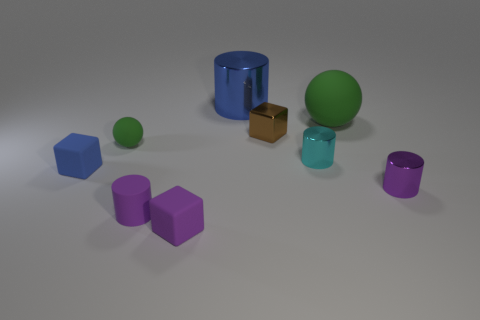Does the green rubber thing that is behind the brown cube have the same shape as the cyan metallic object?
Provide a short and direct response. No. What shape is the tiny blue object?
Provide a short and direct response. Cube. What number of small blue cubes are made of the same material as the big green sphere?
Keep it short and to the point. 1. There is a large metal cylinder; is its color the same as the big matte thing behind the brown object?
Your response must be concise. No. What number of gray shiny cylinders are there?
Keep it short and to the point. 0. Is there a small ball that has the same color as the big matte ball?
Offer a very short reply. Yes. What color is the rubber ball to the right of the tiny purple cylinder left of the tiny purple thing that is to the right of the small metallic block?
Your answer should be compact. Green. Is the large green sphere made of the same material as the blue thing behind the big green sphere?
Your answer should be very brief. No. What material is the big blue cylinder?
Provide a succinct answer. Metal. There is another ball that is the same color as the big sphere; what material is it?
Keep it short and to the point. Rubber. 